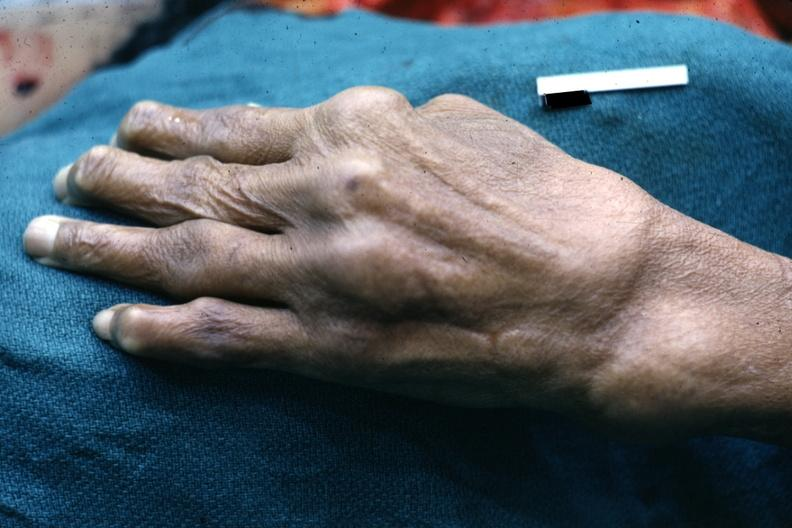what does this image show?
Answer the question using a single word or phrase. Enlarged joints typical of osteoarthritis 